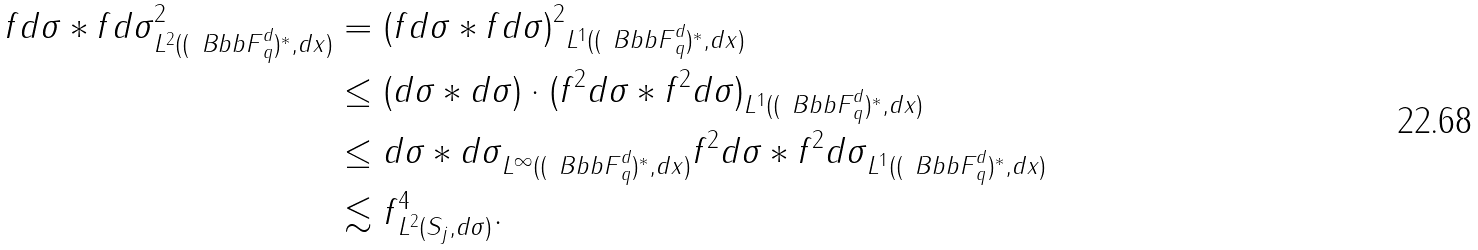Convert formula to latex. <formula><loc_0><loc_0><loc_500><loc_500>\| f d \sigma \ast f d \sigma \| ^ { 2 } _ { L ^ { 2 } ( ( { \ B b b F } _ { q } ^ { d } ) ^ { * } , d x ) } & = \| ( f d \sigma \ast f d \sigma ) ^ { 2 } \| _ { L ^ { 1 } ( ( { \ B b b F } _ { q } ^ { d } ) ^ { * } , d x ) } \\ & \leq \| ( d \sigma \ast d \sigma ) \cdot ( f ^ { 2 } d \sigma \ast f ^ { 2 } d \sigma ) \| _ { L ^ { 1 } ( ( { \ B b b F } _ { q } ^ { d } ) ^ { * } , d x ) } \\ & \leq \| d \sigma \ast d \sigma \| _ { L ^ { \infty } ( ( { \ B b b F } _ { q } ^ { d } ) ^ { * } , d x ) } \| f ^ { 2 } d \sigma \ast f ^ { 2 } d \sigma \| _ { L ^ { 1 } ( ( { \ B b b F } _ { q } ^ { d } ) ^ { * } , d x ) } \\ & \lesssim \| f \| ^ { 4 } _ { L ^ { 2 } ( S _ { j } , d \sigma ) } .</formula> 